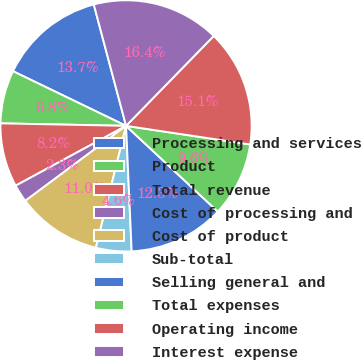<chart> <loc_0><loc_0><loc_500><loc_500><pie_chart><fcel>Processing and services<fcel>Product<fcel>Total revenue<fcel>Cost of processing and<fcel>Cost of product<fcel>Sub-total<fcel>Selling general and<fcel>Total expenses<fcel>Operating income<fcel>Interest expense<nl><fcel>13.7%<fcel>6.85%<fcel>8.22%<fcel>2.28%<fcel>10.96%<fcel>4.57%<fcel>12.33%<fcel>9.59%<fcel>15.07%<fcel>16.44%<nl></chart> 